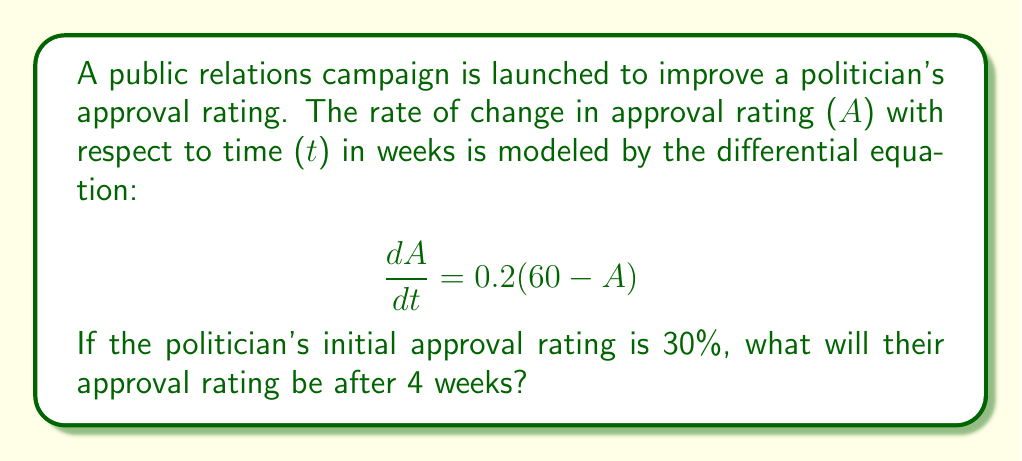Show me your answer to this math problem. To solve this problem, we need to use the following steps:

1) Recognize that this is a first-order linear differential equation.

2) The general solution for this type of equation is:

   $$A(t) = C_1e^{-kt} + A_{\infty}$$

   Where $k$ is the rate constant, $A_{\infty}$ is the equilibrium value, and $C_1$ is a constant determined by initial conditions.

3) From our equation, we can see that $k = 0.2$ and $A_{\infty} = 60$.

4) Substitute these into our general solution:

   $$A(t) = C_1e^{-0.2t} + 60$$

5) Use the initial condition: At $t=0$, $A=30$:

   $$30 = C_1e^{-0.2(0)} + 60$$
   $$30 = C_1 + 60$$
   $$C_1 = -30$$

6) Our particular solution is thus:

   $$A(t) = -30e^{-0.2t} + 60$$

7) To find the approval rating after 4 weeks, substitute $t=4$:

   $$A(4) = -30e^{-0.2(4)} + 60$$
   $$A(4) = -30e^{-0.8} + 60$$
   $$A(4) = -30(0.4493) + 60$$
   $$A(4) = -13.479 + 60 = 46.521$$

8) Convert to a percentage: 46.521% ≈ 46.5%
Answer: The politician's approval rating after 4 weeks will be approximately 46.5%. 